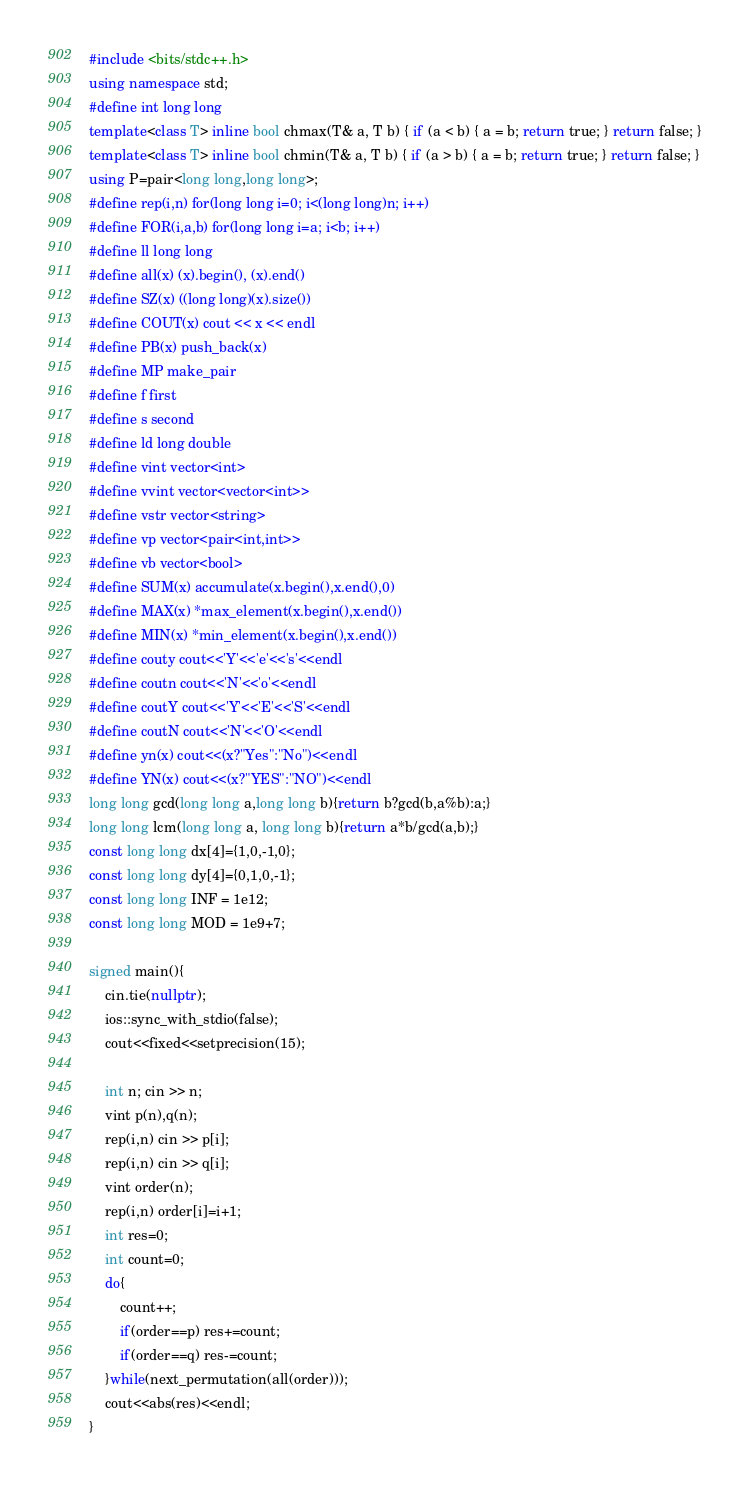Convert code to text. <code><loc_0><loc_0><loc_500><loc_500><_C++_>#include <bits/stdc++.h>
using namespace std;
#define int long long
template<class T> inline bool chmax(T& a, T b) { if (a < b) { a = b; return true; } return false; }
template<class T> inline bool chmin(T& a, T b) { if (a > b) { a = b; return true; } return false; }
using P=pair<long long,long long>;
#define rep(i,n) for(long long i=0; i<(long long)n; i++)
#define FOR(i,a,b) for(long long i=a; i<b; i++)
#define ll long long
#define all(x) (x).begin(), (x).end()
#define SZ(x) ((long long)(x).size())
#define COUT(x) cout << x << endl
#define PB(x) push_back(x)
#define MP make_pair
#define f first
#define s second
#define ld long double
#define vint vector<int>
#define vvint vector<vector<int>>
#define vstr vector<string>
#define vp vector<pair<int,int>>
#define vb vector<bool>
#define SUM(x) accumulate(x.begin(),x.end(),0)
#define MAX(x) *max_element(x.begin(),x.end())
#define MIN(x) *min_element(x.begin(),x.end())
#define couty cout<<'Y'<<'e'<<'s'<<endl
#define coutn cout<<'N'<<'o'<<endl
#define coutY cout<<'Y'<<'E'<<'S'<<endl
#define coutN cout<<'N'<<'O'<<endl
#define yn(x) cout<<(x?"Yes":"No")<<endl
#define YN(x) cout<<(x?"YES":"NO")<<endl
long long gcd(long long a,long long b){return b?gcd(b,a%b):a;}
long long lcm(long long a, long long b){return a*b/gcd(a,b);}
const long long dx[4]={1,0,-1,0};
const long long dy[4]={0,1,0,-1};
const long long INF = 1e12;
const long long MOD = 1e9+7;

signed main(){
    cin.tie(nullptr);
    ios::sync_with_stdio(false);
    cout<<fixed<<setprecision(15);

    int n; cin >> n;
    vint p(n),q(n);
    rep(i,n) cin >> p[i];
    rep(i,n) cin >> q[i];
    vint order(n);
    rep(i,n) order[i]=i+1;
    int res=0;
    int count=0;
    do{
        count++;
        if(order==p) res+=count;
        if(order==q) res-=count;
    }while(next_permutation(all(order)));
    cout<<abs(res)<<endl;
}</code> 